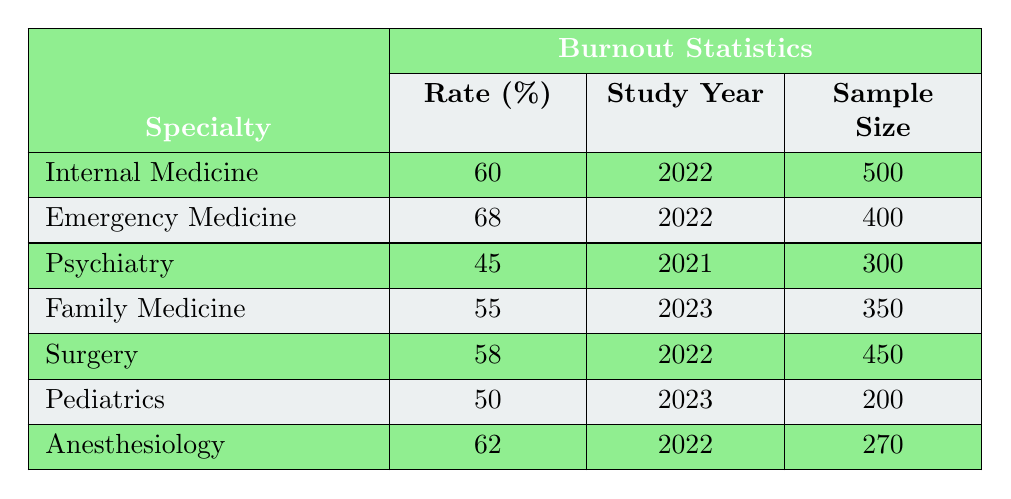What is the burnout rate for Emergency Medicine residents? The table lists the burnout rate for Emergency Medicine as 68%. You can find this percentage directly in the row corresponding to Emergency Medicine.
Answer: 68% Which specialty has the highest burnout rate? The table shows that Emergency Medicine has the highest burnout rate of 68%. You can determine this by comparing all the rates listed in the table and identifying the maximum.
Answer: Emergency Medicine What is the sample size for Psychiatry residents? According to the table, the sample size for Psychiatry residents is 300. This value can be found in the corresponding row for Psychiatry.
Answer: 300 Calculate the average burnout rate of all specialties in the table. To calculate the average burnout rate, first sum all the burnout rates: 60 + 68 + 45 + 55 + 58 + 50 + 62 = 398. Then divide by the number of specialties (7): 398 / 7 ≈ 56.86. Therefore, the average burnout rate is approximately 56.86%.
Answer: 56.86% Is the burnout rate for Family Medicine higher than that for Pediatrics? The burnout rate for Family Medicine is 55%, and that for Pediatrics is 50%. Since 55% is greater than 50%, the statement is true. We can directly compare these two rates to reach this conclusion.
Answer: Yes What is the difference in burnout rates between Anesthesiology and Internal Medicine? The burnout rate for Anesthesiology is 62%, and for Internal Medicine, it is 60%. The difference is calculated as 62 - 60 = 2%. Thus, Anesthesiology has a 2% higher burnout rate than Internal Medicine.
Answer: 2% Are there any specialties with a burnout rate below 50%? Looking at the table, the lowest burnout rate listed is 45% for Psychiatry. Since 45% is below 50%, there is at least one specialty (Psychiatry) that meets this criterion.
Answer: Yes What is the total sample size for all specialties listed? The total sample size can be calculated by adding the sample sizes: 500 (Internal Medicine) + 400 (Emergency Medicine) + 300 (Psychiatry) + 350 (Family Medicine) + 450 (Surgery) + 200 (Pediatrics) + 270 (Anesthesiology) = 2970. Therefore, the total sample size is 2970.
Answer: 2970 